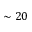<formula> <loc_0><loc_0><loc_500><loc_500>\sim 2 0</formula> 